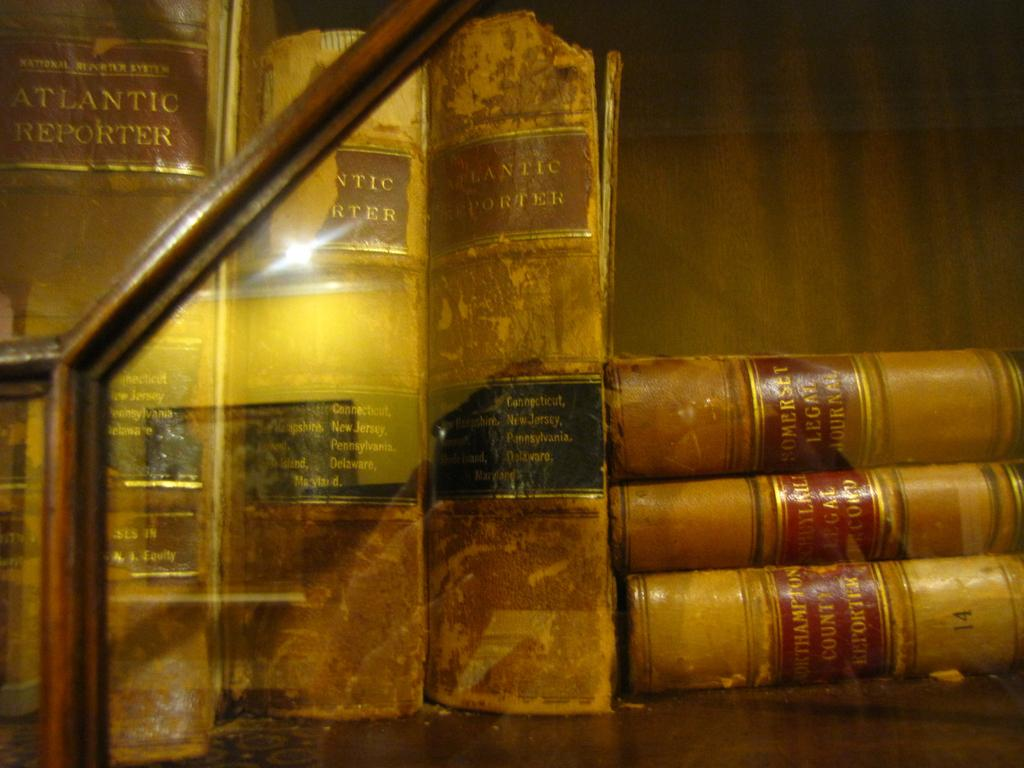<image>
Render a clear and concise summary of the photo. old books on a shelf, three Atlantic Reporter standing and three Southampton County Reporter laying flat 